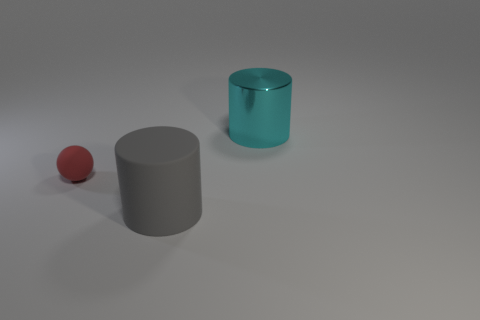The cylinder that is the same size as the gray object is what color?
Ensure brevity in your answer.  Cyan. There is a rubber thing that is left of the big gray rubber cylinder; is there a gray thing that is behind it?
Offer a very short reply. No. What material is the thing on the right side of the gray rubber thing?
Your answer should be very brief. Metal. Do the object that is behind the small red thing and the cylinder in front of the tiny matte object have the same material?
Provide a succinct answer. No. Is the number of red matte things that are in front of the cyan shiny cylinder the same as the number of big cylinders that are in front of the tiny red sphere?
Give a very brief answer. Yes. What number of other spheres are made of the same material as the tiny ball?
Your response must be concise. 0. There is a red thing that is to the left of the cylinder on the right side of the big gray matte object; what is its size?
Offer a terse response. Small. Do the thing right of the large gray cylinder and the big object in front of the red matte ball have the same shape?
Give a very brief answer. Yes. Are there the same number of small rubber objects that are on the right side of the rubber cylinder and brown cylinders?
Give a very brief answer. Yes. What is the color of the large metal object that is the same shape as the big rubber object?
Your answer should be very brief. Cyan. 